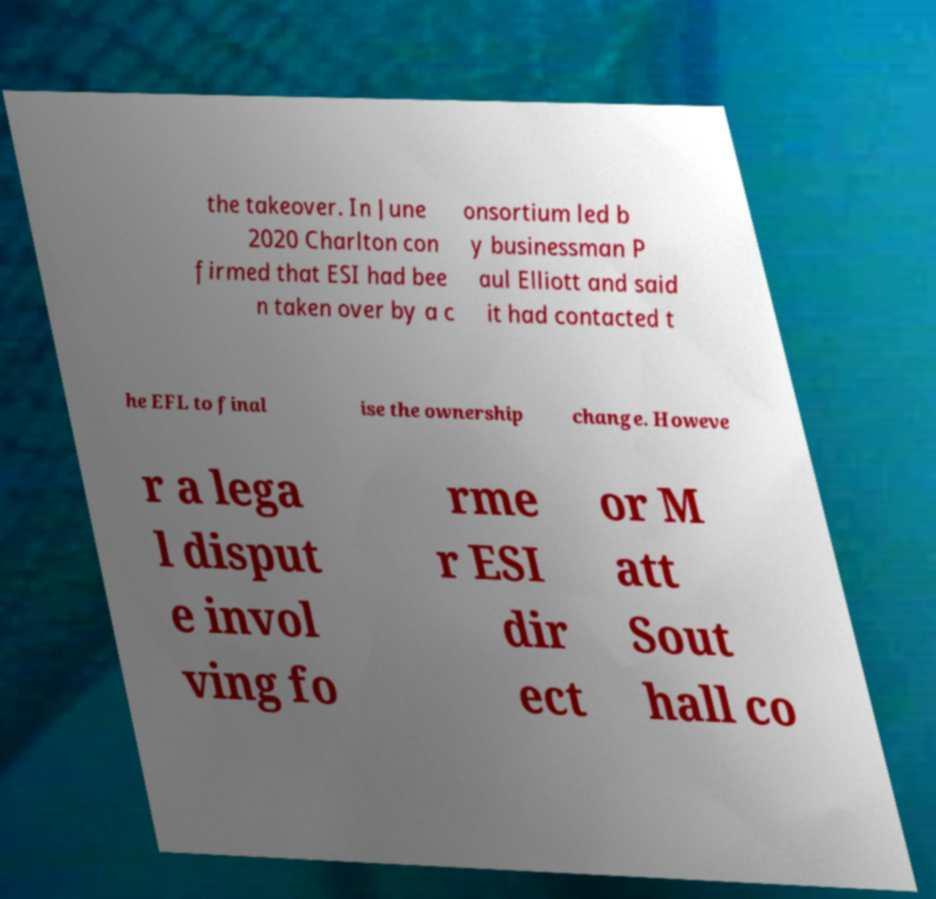Can you accurately transcribe the text from the provided image for me? the takeover. In June 2020 Charlton con firmed that ESI had bee n taken over by a c onsortium led b y businessman P aul Elliott and said it had contacted t he EFL to final ise the ownership change. Howeve r a lega l disput e invol ving fo rme r ESI dir ect or M att Sout hall co 